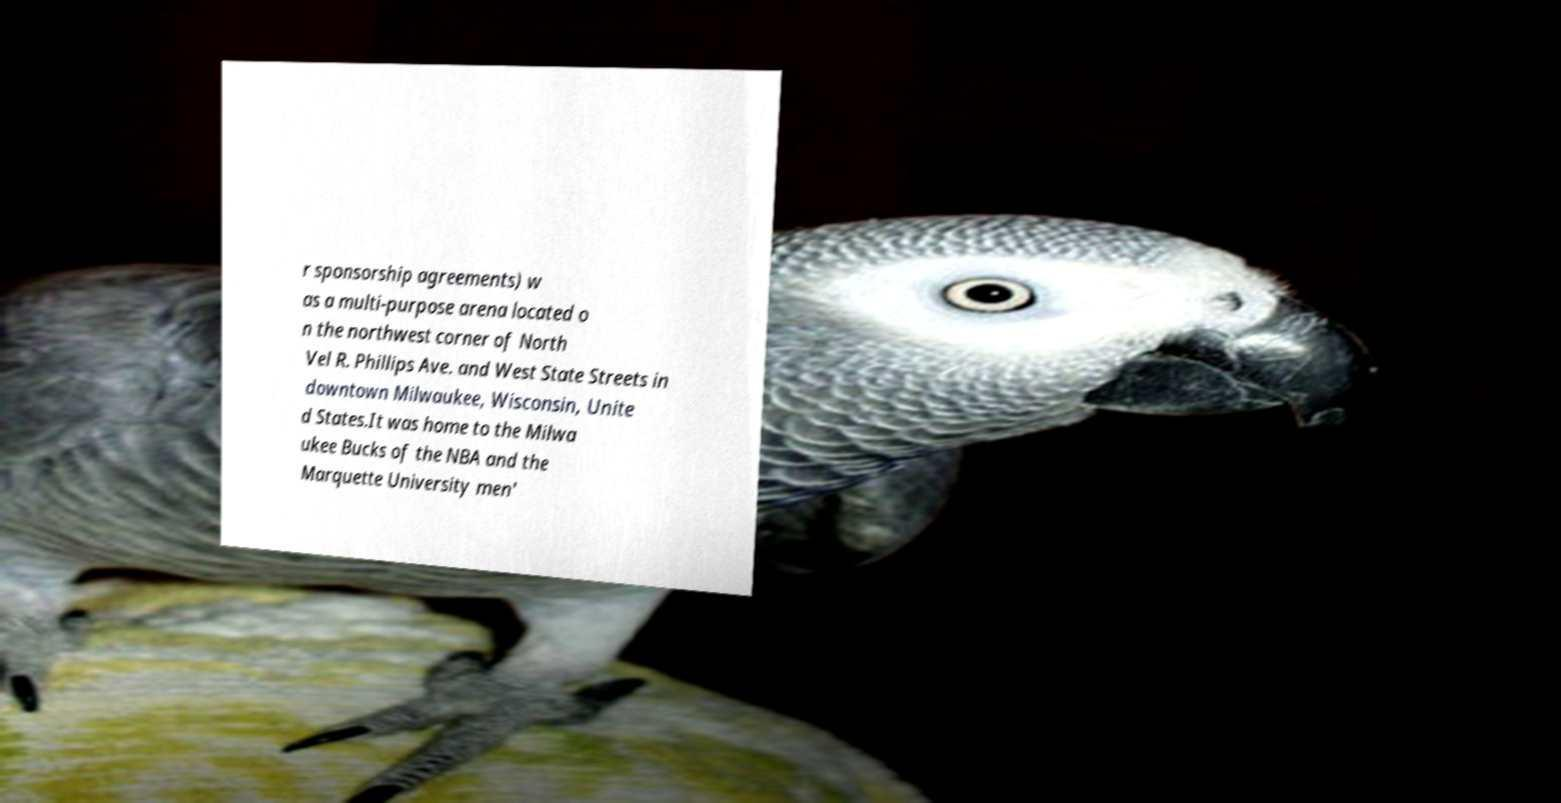Could you assist in decoding the text presented in this image and type it out clearly? r sponsorship agreements) w as a multi-purpose arena located o n the northwest corner of North Vel R. Phillips Ave. and West State Streets in downtown Milwaukee, Wisconsin, Unite d States.It was home to the Milwa ukee Bucks of the NBA and the Marquette University men' 